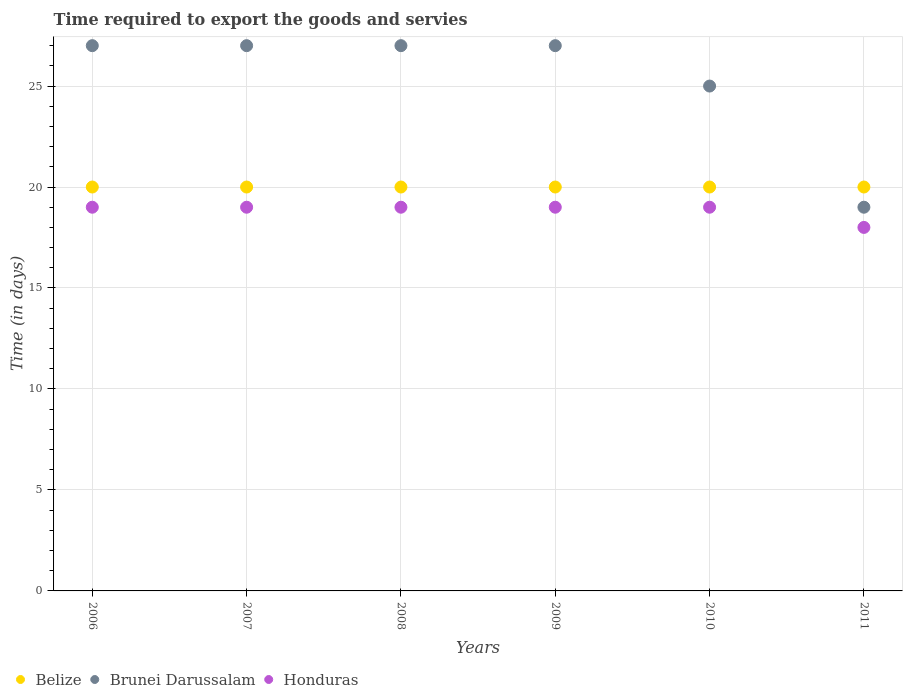How many different coloured dotlines are there?
Provide a short and direct response. 3. What is the number of days required to export the goods and services in Belize in 2006?
Offer a terse response. 20. Across all years, what is the maximum number of days required to export the goods and services in Honduras?
Your response must be concise. 19. In which year was the number of days required to export the goods and services in Brunei Darussalam minimum?
Give a very brief answer. 2011. What is the total number of days required to export the goods and services in Brunei Darussalam in the graph?
Keep it short and to the point. 152. What is the difference between the number of days required to export the goods and services in Brunei Darussalam in 2006 and that in 2009?
Make the answer very short. 0. What is the difference between the number of days required to export the goods and services in Honduras in 2006 and the number of days required to export the goods and services in Belize in 2008?
Your response must be concise. -1. What is the average number of days required to export the goods and services in Brunei Darussalam per year?
Your answer should be very brief. 25.33. What is the ratio of the number of days required to export the goods and services in Belize in 2008 to that in 2011?
Ensure brevity in your answer.  1. Is the number of days required to export the goods and services in Belize in 2010 less than that in 2011?
Your answer should be very brief. No. Is the difference between the number of days required to export the goods and services in Belize in 2007 and 2010 greater than the difference between the number of days required to export the goods and services in Brunei Darussalam in 2007 and 2010?
Provide a short and direct response. No. What is the difference between the highest and the second highest number of days required to export the goods and services in Brunei Darussalam?
Ensure brevity in your answer.  0. What is the difference between the highest and the lowest number of days required to export the goods and services in Honduras?
Offer a very short reply. 1. Is the sum of the number of days required to export the goods and services in Brunei Darussalam in 2007 and 2009 greater than the maximum number of days required to export the goods and services in Honduras across all years?
Your response must be concise. Yes. Is the number of days required to export the goods and services in Honduras strictly greater than the number of days required to export the goods and services in Brunei Darussalam over the years?
Keep it short and to the point. No. How many dotlines are there?
Offer a terse response. 3. How many years are there in the graph?
Ensure brevity in your answer.  6. Where does the legend appear in the graph?
Offer a very short reply. Bottom left. How many legend labels are there?
Offer a terse response. 3. What is the title of the graph?
Give a very brief answer. Time required to export the goods and servies. Does "Bahamas" appear as one of the legend labels in the graph?
Provide a succinct answer. No. What is the label or title of the Y-axis?
Make the answer very short. Time (in days). What is the Time (in days) of Belize in 2007?
Provide a short and direct response. 20. What is the Time (in days) in Honduras in 2007?
Ensure brevity in your answer.  19. What is the Time (in days) in Brunei Darussalam in 2008?
Keep it short and to the point. 27. What is the Time (in days) of Honduras in 2008?
Give a very brief answer. 19. What is the Time (in days) of Belize in 2009?
Give a very brief answer. 20. What is the Time (in days) in Belize in 2010?
Provide a short and direct response. 20. What is the Time (in days) in Brunei Darussalam in 2010?
Offer a terse response. 25. Across all years, what is the maximum Time (in days) in Belize?
Give a very brief answer. 20. Across all years, what is the maximum Time (in days) of Brunei Darussalam?
Keep it short and to the point. 27. Across all years, what is the minimum Time (in days) in Belize?
Offer a very short reply. 20. What is the total Time (in days) in Belize in the graph?
Provide a short and direct response. 120. What is the total Time (in days) in Brunei Darussalam in the graph?
Your answer should be compact. 152. What is the total Time (in days) in Honduras in the graph?
Offer a terse response. 113. What is the difference between the Time (in days) of Belize in 2006 and that in 2008?
Give a very brief answer. 0. What is the difference between the Time (in days) in Brunei Darussalam in 2006 and that in 2008?
Offer a terse response. 0. What is the difference between the Time (in days) of Belize in 2006 and that in 2009?
Make the answer very short. 0. What is the difference between the Time (in days) in Brunei Darussalam in 2006 and that in 2009?
Offer a very short reply. 0. What is the difference between the Time (in days) in Belize in 2006 and that in 2010?
Provide a succinct answer. 0. What is the difference between the Time (in days) in Honduras in 2006 and that in 2010?
Make the answer very short. 0. What is the difference between the Time (in days) of Belize in 2007 and that in 2009?
Your answer should be very brief. 0. What is the difference between the Time (in days) in Honduras in 2007 and that in 2009?
Provide a succinct answer. 0. What is the difference between the Time (in days) in Belize in 2007 and that in 2010?
Make the answer very short. 0. What is the difference between the Time (in days) of Honduras in 2007 and that in 2011?
Give a very brief answer. 1. What is the difference between the Time (in days) of Honduras in 2008 and that in 2009?
Your answer should be compact. 0. What is the difference between the Time (in days) of Belize in 2008 and that in 2010?
Offer a terse response. 0. What is the difference between the Time (in days) of Brunei Darussalam in 2008 and that in 2010?
Provide a succinct answer. 2. What is the difference between the Time (in days) in Belize in 2008 and that in 2011?
Keep it short and to the point. 0. What is the difference between the Time (in days) of Brunei Darussalam in 2009 and that in 2010?
Your answer should be very brief. 2. What is the difference between the Time (in days) of Honduras in 2009 and that in 2010?
Offer a terse response. 0. What is the difference between the Time (in days) in Honduras in 2009 and that in 2011?
Keep it short and to the point. 1. What is the difference between the Time (in days) of Honduras in 2010 and that in 2011?
Your response must be concise. 1. What is the difference between the Time (in days) in Belize in 2006 and the Time (in days) in Brunei Darussalam in 2007?
Offer a terse response. -7. What is the difference between the Time (in days) of Belize in 2006 and the Time (in days) of Honduras in 2007?
Provide a succinct answer. 1. What is the difference between the Time (in days) of Belize in 2006 and the Time (in days) of Brunei Darussalam in 2009?
Keep it short and to the point. -7. What is the difference between the Time (in days) of Belize in 2006 and the Time (in days) of Honduras in 2009?
Provide a succinct answer. 1. What is the difference between the Time (in days) of Belize in 2006 and the Time (in days) of Honduras in 2010?
Your answer should be very brief. 1. What is the difference between the Time (in days) of Belize in 2007 and the Time (in days) of Honduras in 2008?
Your answer should be compact. 1. What is the difference between the Time (in days) of Brunei Darussalam in 2007 and the Time (in days) of Honduras in 2008?
Provide a short and direct response. 8. What is the difference between the Time (in days) of Belize in 2007 and the Time (in days) of Brunei Darussalam in 2009?
Keep it short and to the point. -7. What is the difference between the Time (in days) in Belize in 2007 and the Time (in days) in Honduras in 2009?
Your answer should be compact. 1. What is the difference between the Time (in days) of Belize in 2007 and the Time (in days) of Brunei Darussalam in 2010?
Provide a succinct answer. -5. What is the difference between the Time (in days) of Belize in 2007 and the Time (in days) of Honduras in 2010?
Offer a very short reply. 1. What is the difference between the Time (in days) of Brunei Darussalam in 2007 and the Time (in days) of Honduras in 2010?
Keep it short and to the point. 8. What is the difference between the Time (in days) in Belize in 2007 and the Time (in days) in Brunei Darussalam in 2011?
Your answer should be very brief. 1. What is the difference between the Time (in days) in Belize in 2007 and the Time (in days) in Honduras in 2011?
Ensure brevity in your answer.  2. What is the difference between the Time (in days) in Brunei Darussalam in 2007 and the Time (in days) in Honduras in 2011?
Keep it short and to the point. 9. What is the difference between the Time (in days) of Belize in 2008 and the Time (in days) of Honduras in 2009?
Keep it short and to the point. 1. What is the difference between the Time (in days) in Belize in 2008 and the Time (in days) in Brunei Darussalam in 2010?
Give a very brief answer. -5. What is the difference between the Time (in days) of Belize in 2008 and the Time (in days) of Honduras in 2010?
Provide a short and direct response. 1. What is the difference between the Time (in days) in Belize in 2008 and the Time (in days) in Honduras in 2011?
Keep it short and to the point. 2. What is the difference between the Time (in days) of Belize in 2009 and the Time (in days) of Honduras in 2010?
Give a very brief answer. 1. What is the difference between the Time (in days) of Belize in 2009 and the Time (in days) of Brunei Darussalam in 2011?
Provide a short and direct response. 1. What is the difference between the Time (in days) of Brunei Darussalam in 2009 and the Time (in days) of Honduras in 2011?
Ensure brevity in your answer.  9. What is the difference between the Time (in days) of Belize in 2010 and the Time (in days) of Brunei Darussalam in 2011?
Your answer should be compact. 1. What is the difference between the Time (in days) in Brunei Darussalam in 2010 and the Time (in days) in Honduras in 2011?
Offer a terse response. 7. What is the average Time (in days) in Belize per year?
Your answer should be compact. 20. What is the average Time (in days) of Brunei Darussalam per year?
Offer a very short reply. 25.33. What is the average Time (in days) of Honduras per year?
Provide a succinct answer. 18.83. In the year 2006, what is the difference between the Time (in days) in Belize and Time (in days) in Brunei Darussalam?
Ensure brevity in your answer.  -7. In the year 2006, what is the difference between the Time (in days) in Belize and Time (in days) in Honduras?
Provide a short and direct response. 1. In the year 2007, what is the difference between the Time (in days) in Belize and Time (in days) in Brunei Darussalam?
Provide a short and direct response. -7. In the year 2008, what is the difference between the Time (in days) of Belize and Time (in days) of Brunei Darussalam?
Your answer should be compact. -7. In the year 2008, what is the difference between the Time (in days) in Belize and Time (in days) in Honduras?
Provide a succinct answer. 1. In the year 2010, what is the difference between the Time (in days) of Brunei Darussalam and Time (in days) of Honduras?
Ensure brevity in your answer.  6. In the year 2011, what is the difference between the Time (in days) in Belize and Time (in days) in Brunei Darussalam?
Your response must be concise. 1. What is the ratio of the Time (in days) in Belize in 2006 to that in 2009?
Keep it short and to the point. 1. What is the ratio of the Time (in days) in Brunei Darussalam in 2006 to that in 2009?
Give a very brief answer. 1. What is the ratio of the Time (in days) of Honduras in 2006 to that in 2009?
Keep it short and to the point. 1. What is the ratio of the Time (in days) in Belize in 2006 to that in 2010?
Give a very brief answer. 1. What is the ratio of the Time (in days) of Brunei Darussalam in 2006 to that in 2010?
Keep it short and to the point. 1.08. What is the ratio of the Time (in days) of Honduras in 2006 to that in 2010?
Your answer should be compact. 1. What is the ratio of the Time (in days) in Brunei Darussalam in 2006 to that in 2011?
Offer a terse response. 1.42. What is the ratio of the Time (in days) of Honduras in 2006 to that in 2011?
Your response must be concise. 1.06. What is the ratio of the Time (in days) of Belize in 2007 to that in 2008?
Make the answer very short. 1. What is the ratio of the Time (in days) of Brunei Darussalam in 2007 to that in 2008?
Your answer should be compact. 1. What is the ratio of the Time (in days) in Belize in 2007 to that in 2009?
Your answer should be very brief. 1. What is the ratio of the Time (in days) in Brunei Darussalam in 2007 to that in 2009?
Ensure brevity in your answer.  1. What is the ratio of the Time (in days) in Belize in 2007 to that in 2011?
Your response must be concise. 1. What is the ratio of the Time (in days) of Brunei Darussalam in 2007 to that in 2011?
Offer a very short reply. 1.42. What is the ratio of the Time (in days) in Honduras in 2007 to that in 2011?
Offer a very short reply. 1.06. What is the ratio of the Time (in days) in Brunei Darussalam in 2008 to that in 2009?
Give a very brief answer. 1. What is the ratio of the Time (in days) of Honduras in 2008 to that in 2009?
Your answer should be very brief. 1. What is the ratio of the Time (in days) of Belize in 2008 to that in 2010?
Provide a short and direct response. 1. What is the ratio of the Time (in days) of Honduras in 2008 to that in 2010?
Offer a terse response. 1. What is the ratio of the Time (in days) in Belize in 2008 to that in 2011?
Offer a terse response. 1. What is the ratio of the Time (in days) of Brunei Darussalam in 2008 to that in 2011?
Make the answer very short. 1.42. What is the ratio of the Time (in days) in Honduras in 2008 to that in 2011?
Your answer should be compact. 1.06. What is the ratio of the Time (in days) of Belize in 2009 to that in 2010?
Make the answer very short. 1. What is the ratio of the Time (in days) of Honduras in 2009 to that in 2010?
Offer a very short reply. 1. What is the ratio of the Time (in days) in Brunei Darussalam in 2009 to that in 2011?
Your response must be concise. 1.42. What is the ratio of the Time (in days) of Honduras in 2009 to that in 2011?
Provide a short and direct response. 1.06. What is the ratio of the Time (in days) of Brunei Darussalam in 2010 to that in 2011?
Your answer should be very brief. 1.32. What is the ratio of the Time (in days) of Honduras in 2010 to that in 2011?
Make the answer very short. 1.06. What is the difference between the highest and the second highest Time (in days) in Brunei Darussalam?
Your answer should be compact. 0. What is the difference between the highest and the second highest Time (in days) of Honduras?
Your answer should be very brief. 0. What is the difference between the highest and the lowest Time (in days) in Honduras?
Your response must be concise. 1. 